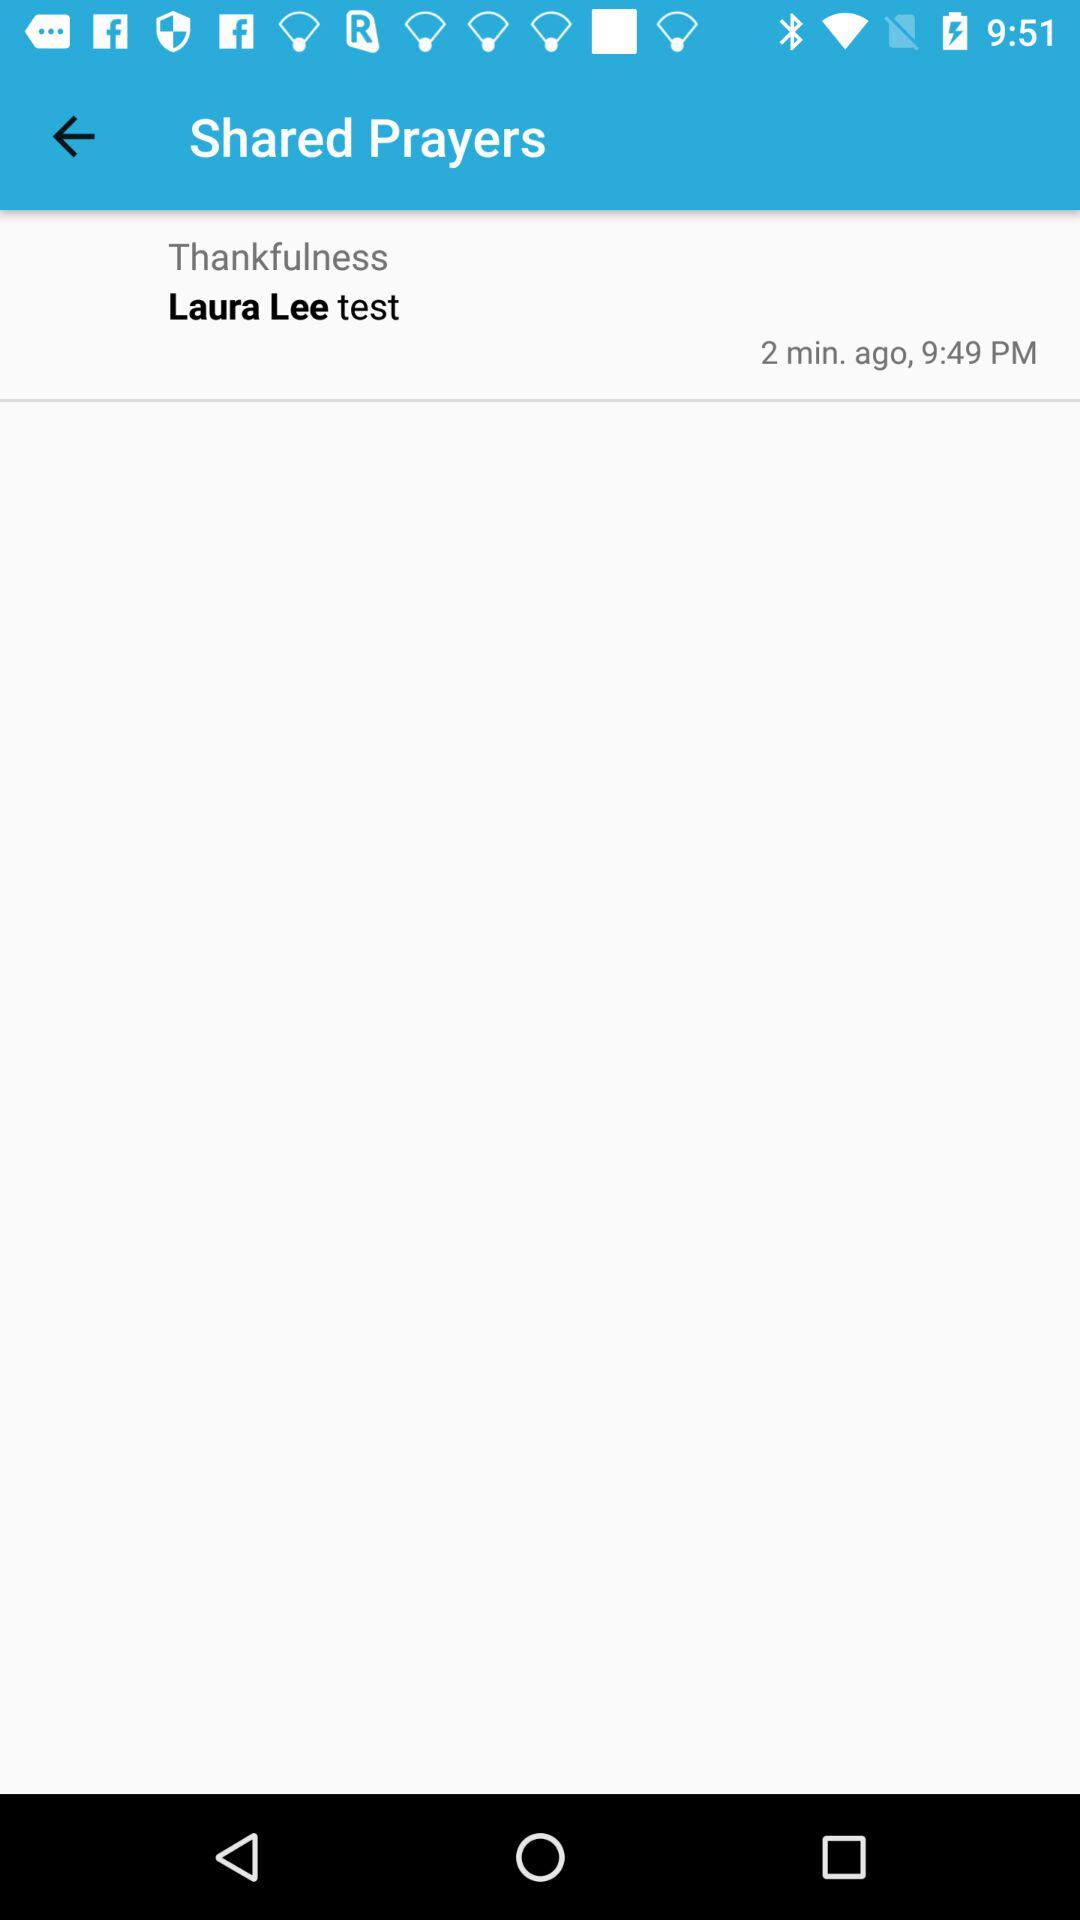What test name is shown on the screen? The test name shown on the screen is the Laura Lee test. 